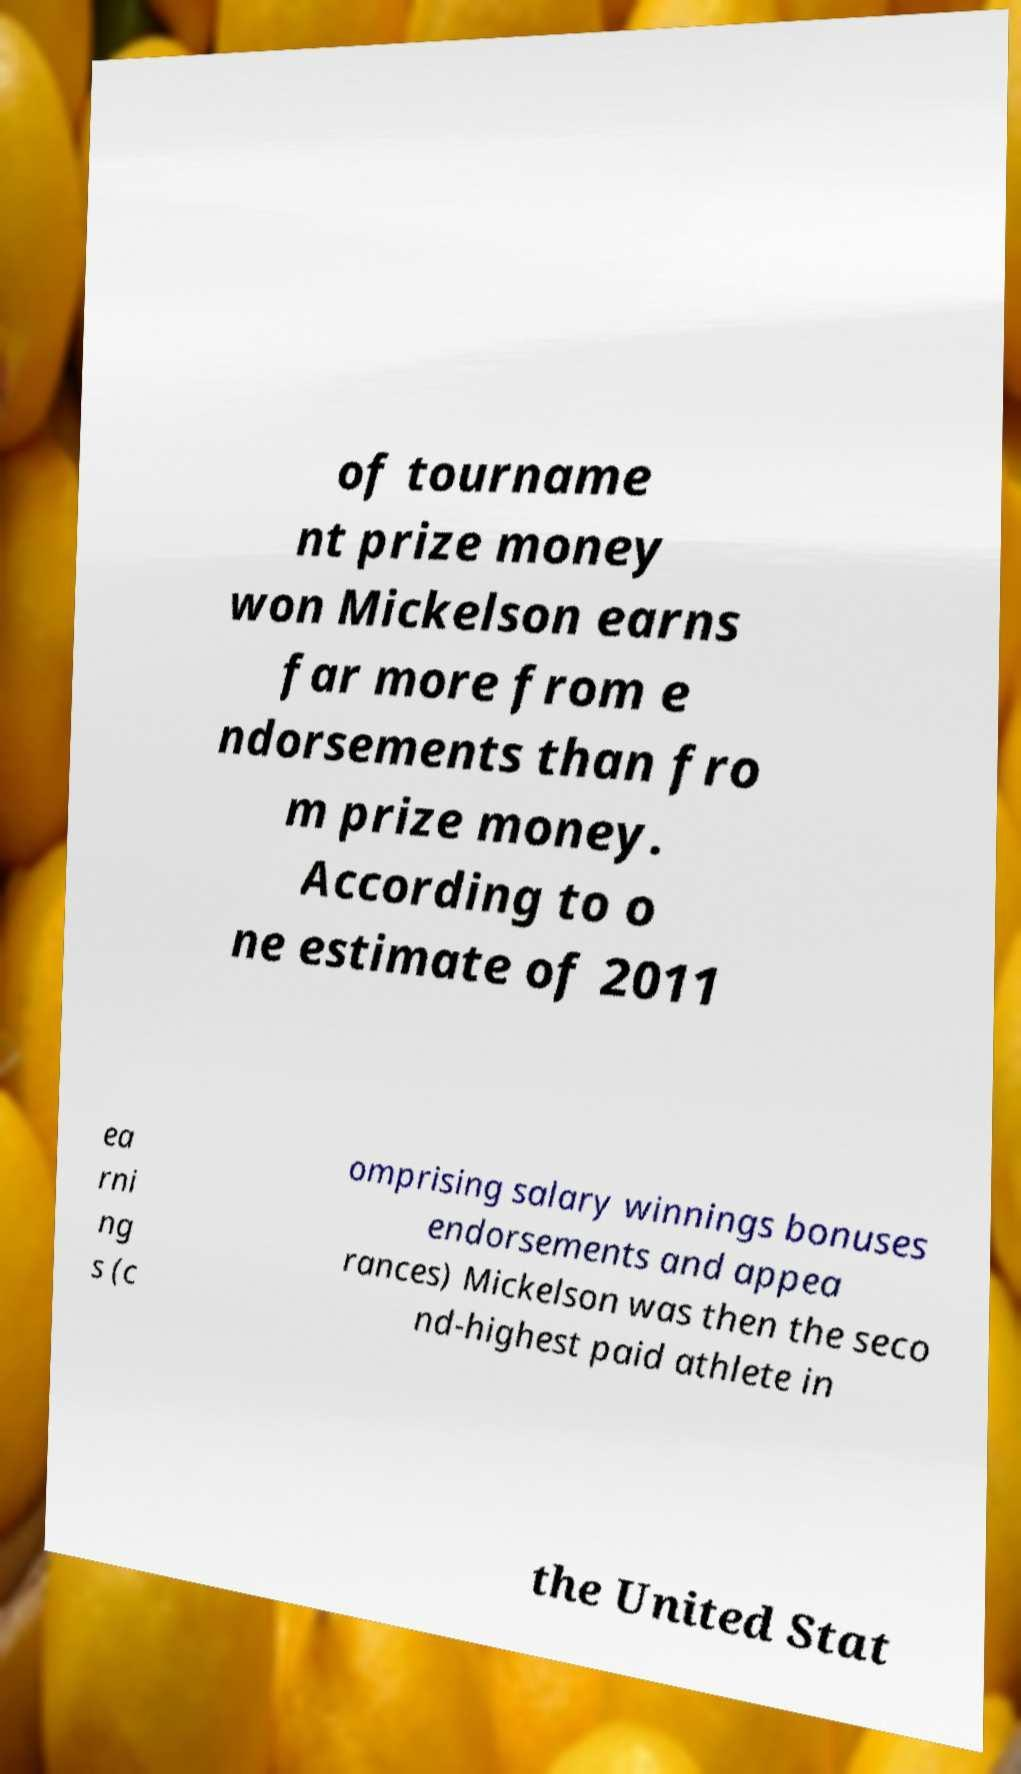Could you assist in decoding the text presented in this image and type it out clearly? of tourname nt prize money won Mickelson earns far more from e ndorsements than fro m prize money. According to o ne estimate of 2011 ea rni ng s (c omprising salary winnings bonuses endorsements and appea rances) Mickelson was then the seco nd-highest paid athlete in the United Stat 